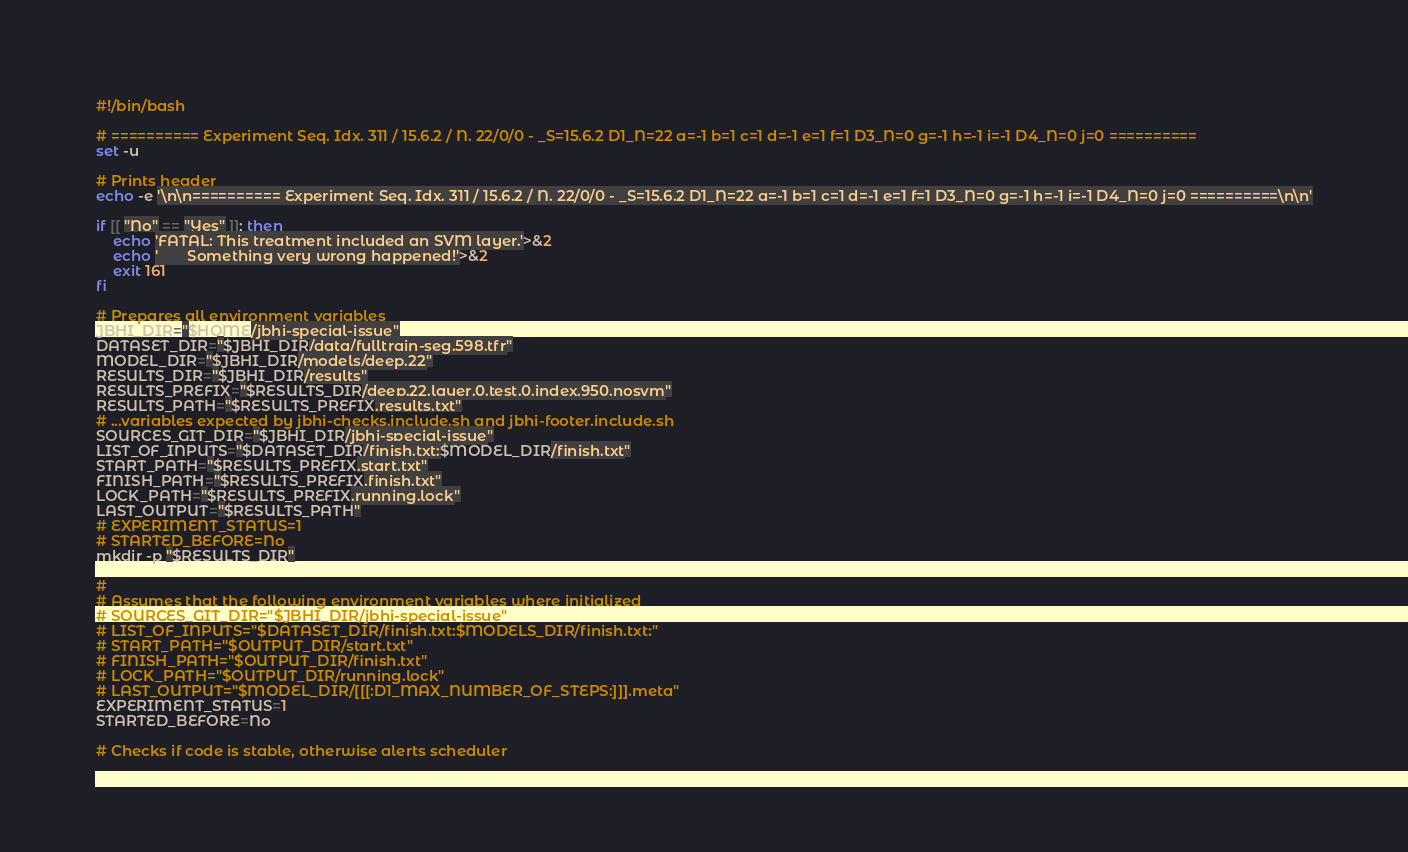<code> <loc_0><loc_0><loc_500><loc_500><_Bash_>#!/bin/bash

# ========== Experiment Seq. Idx. 311 / 15.6.2 / N. 22/0/0 - _S=15.6.2 D1_N=22 a=-1 b=1 c=1 d=-1 e=1 f=1 D3_N=0 g=-1 h=-1 i=-1 D4_N=0 j=0 ==========
set -u

# Prints header
echo -e '\n\n========== Experiment Seq. Idx. 311 / 15.6.2 / N. 22/0/0 - _S=15.6.2 D1_N=22 a=-1 b=1 c=1 d=-1 e=1 f=1 D3_N=0 g=-1 h=-1 i=-1 D4_N=0 j=0 ==========\n\n'

if [[ "No" == "Yes" ]]; then
    echo 'FATAL: This treatment included an SVM layer.'>&2
    echo '       Something very wrong happened!'>&2
    exit 161
fi

# Prepares all environment variables
JBHI_DIR="$HOME/jbhi-special-issue"
DATASET_DIR="$JBHI_DIR/data/fulltrain-seg.598.tfr"
MODEL_DIR="$JBHI_DIR/models/deep.22"
RESULTS_DIR="$JBHI_DIR/results"
RESULTS_PREFIX="$RESULTS_DIR/deep.22.layer.0.test.0.index.950.nosvm"
RESULTS_PATH="$RESULTS_PREFIX.results.txt"
# ...variables expected by jbhi-checks.include.sh and jbhi-footer.include.sh
SOURCES_GIT_DIR="$JBHI_DIR/jbhi-special-issue"
LIST_OF_INPUTS="$DATASET_DIR/finish.txt:$MODEL_DIR/finish.txt"
START_PATH="$RESULTS_PREFIX.start.txt"
FINISH_PATH="$RESULTS_PREFIX.finish.txt"
LOCK_PATH="$RESULTS_PREFIX.running.lock"
LAST_OUTPUT="$RESULTS_PATH"
# EXPERIMENT_STATUS=1
# STARTED_BEFORE=No
mkdir -p "$RESULTS_DIR"

#
# Assumes that the following environment variables where initialized
# SOURCES_GIT_DIR="$JBHI_DIR/jbhi-special-issue"
# LIST_OF_INPUTS="$DATASET_DIR/finish.txt:$MODELS_DIR/finish.txt:"
# START_PATH="$OUTPUT_DIR/start.txt"
# FINISH_PATH="$OUTPUT_DIR/finish.txt"
# LOCK_PATH="$OUTPUT_DIR/running.lock"
# LAST_OUTPUT="$MODEL_DIR/[[[:D1_MAX_NUMBER_OF_STEPS:]]].meta"
EXPERIMENT_STATUS=1
STARTED_BEFORE=No

# Checks if code is stable, otherwise alerts scheduler</code> 